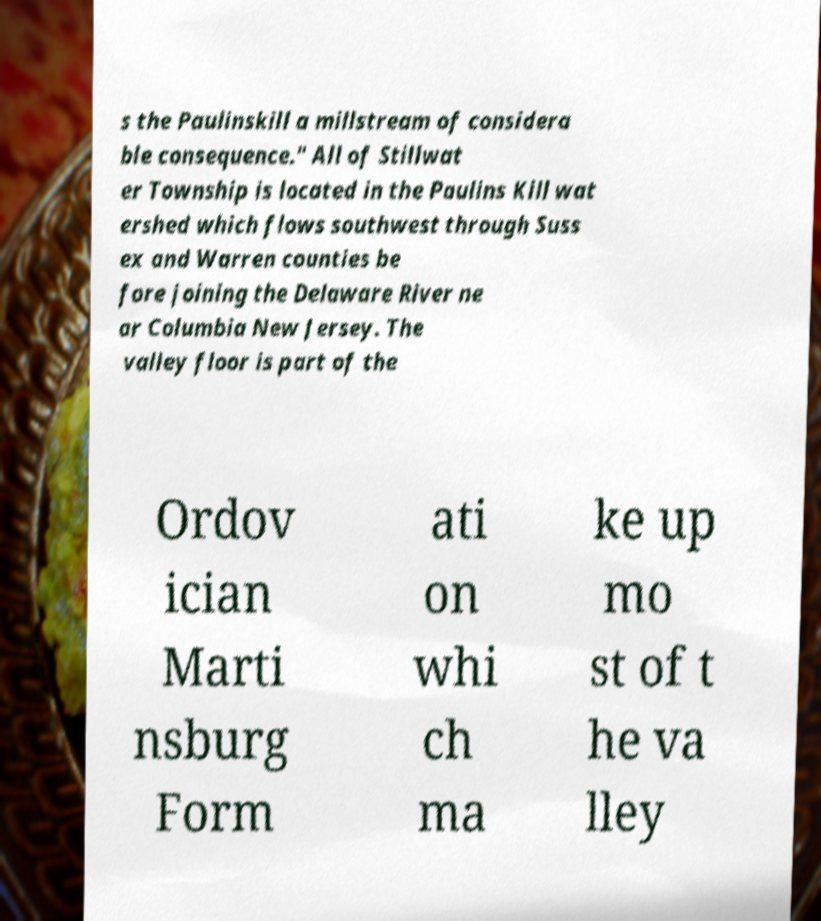I need the written content from this picture converted into text. Can you do that? s the Paulinskill a millstream of considera ble consequence." All of Stillwat er Township is located in the Paulins Kill wat ershed which flows southwest through Suss ex and Warren counties be fore joining the Delaware River ne ar Columbia New Jersey. The valley floor is part of the Ordov ician Marti nsburg Form ati on whi ch ma ke up mo st of t he va lley 